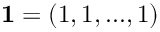<formula> <loc_0><loc_0><loc_500><loc_500>1 = ( 1 , 1 , \dots , 1 )</formula> 